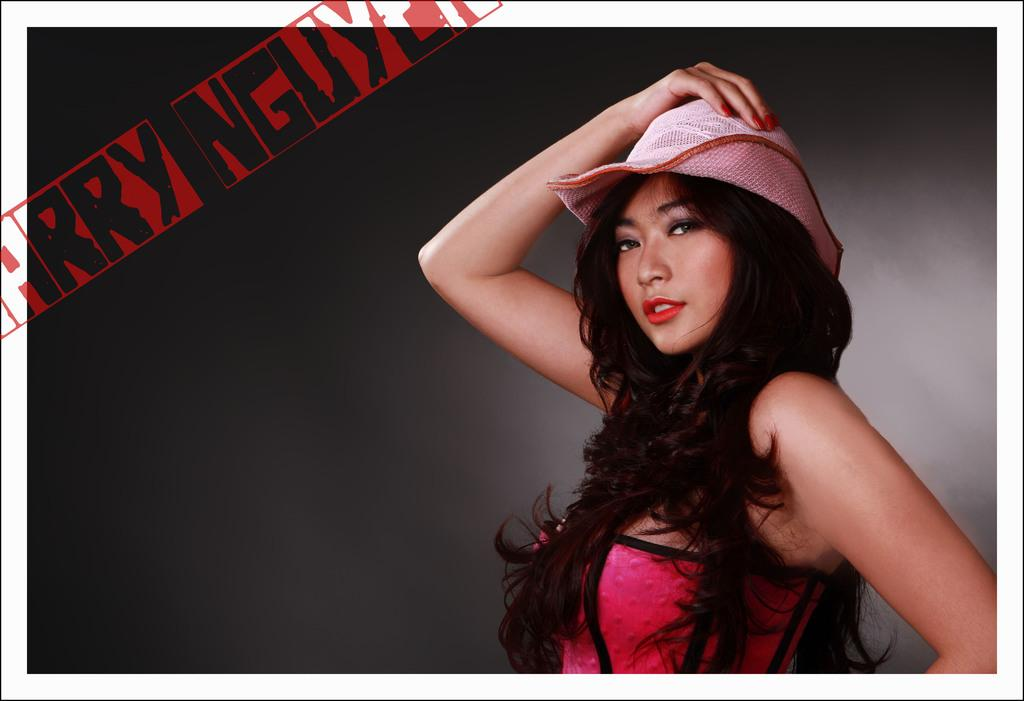Who is the main subject in the picture? There is a woman in the picture. What is the woman doing in the image? The woman is giving a pose. What color is the top that the woman is wearing? The woman is wearing a pink top. What type of accessory is the woman wearing on her head? The woman is wearing a hat. How many pizzas are visible in the image? There are no pizzas present in the image. Can you tell me the name of the woman's friend in the image? There is no friend visible in the image, only the woman is present. 